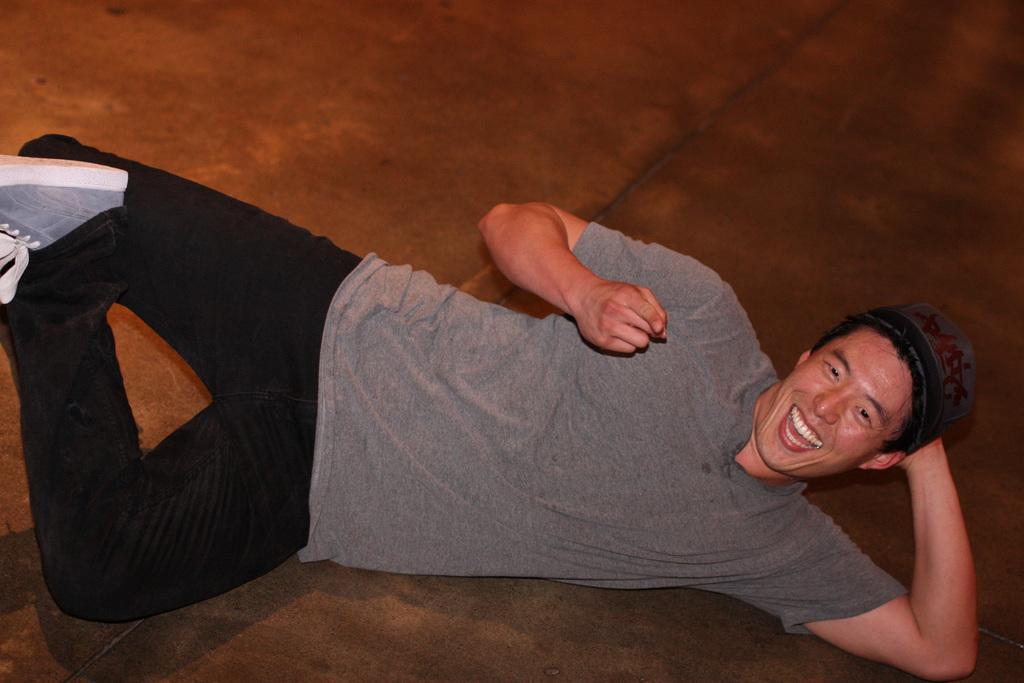Please provide a concise description of this image. In this image we can see a man with a cap and a t shirt smiling and lying on the floor. 